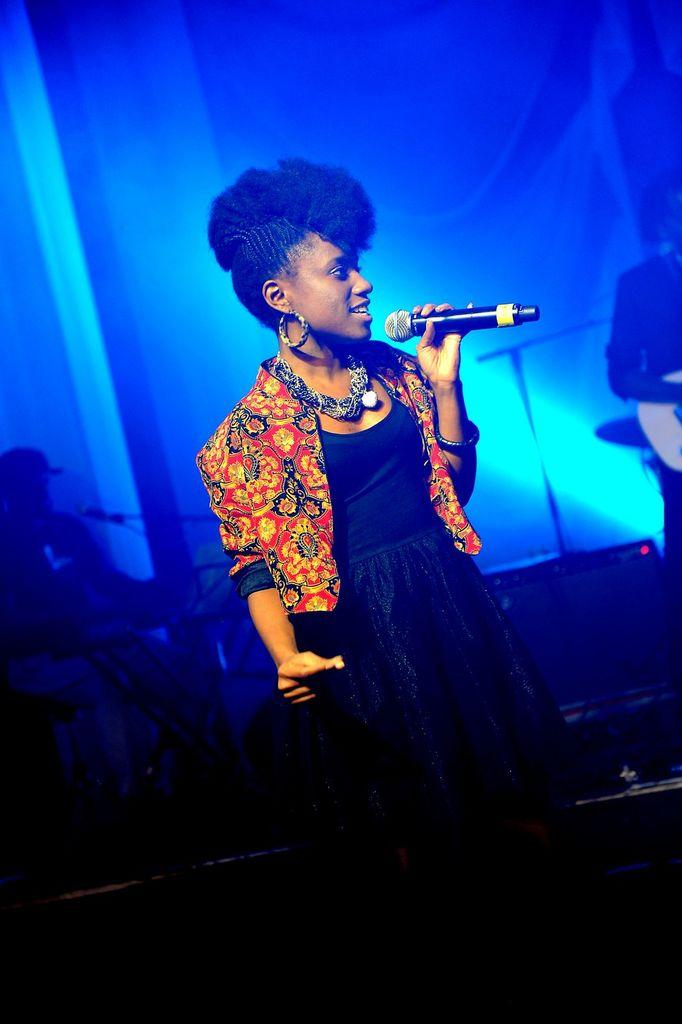Who is the main subject in the image? There is a woman in the image. What is the woman wearing? The woman is wearing a black dress. What is the woman holding in the image? The woman is holding a microphone. What can be seen in the background of the image? There are music instruments and a blue wall in the background. Is the woman sitting on a throne in the image? No, there is no throne present in the image. What type of leather is used to make the woman's dress? The woman's dress is not made of leather; it is a black dress. 